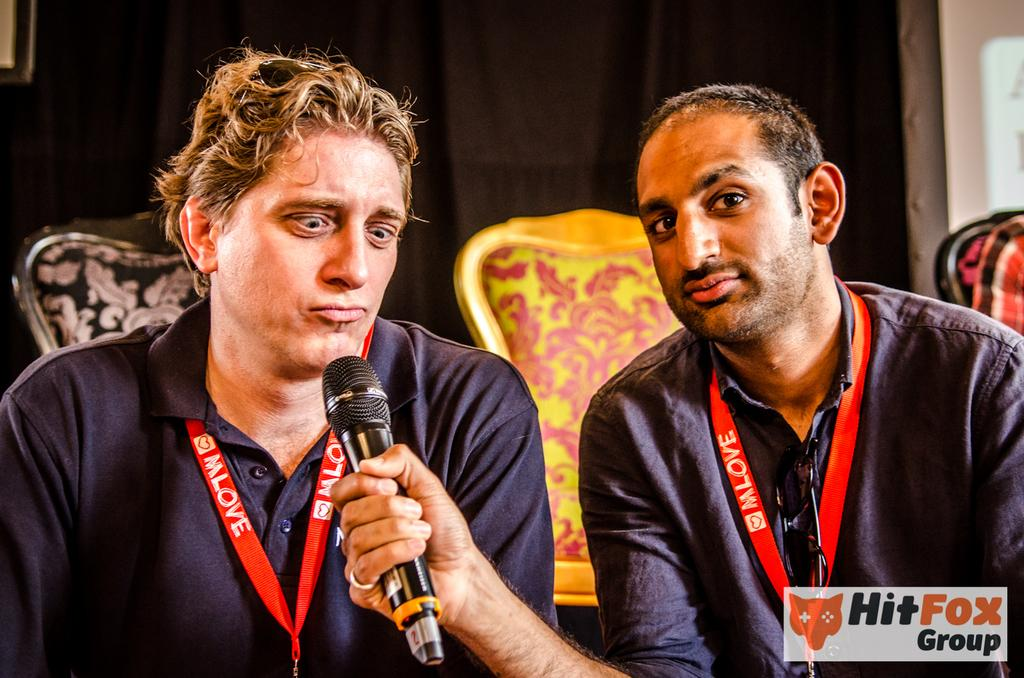What are the men in the image doing? The men in the image are sitting on chairs. Can you describe what one of the men is holding? One man is holding a microphone in his hand. Are there any other chairs visible in the image? Yes, there are additional chairs on the floor in the background. What type of clover is growing on the floor near the chairs? There is no clover visible in the image; it is a scene with men sitting on chairs and one holding a microphone. 